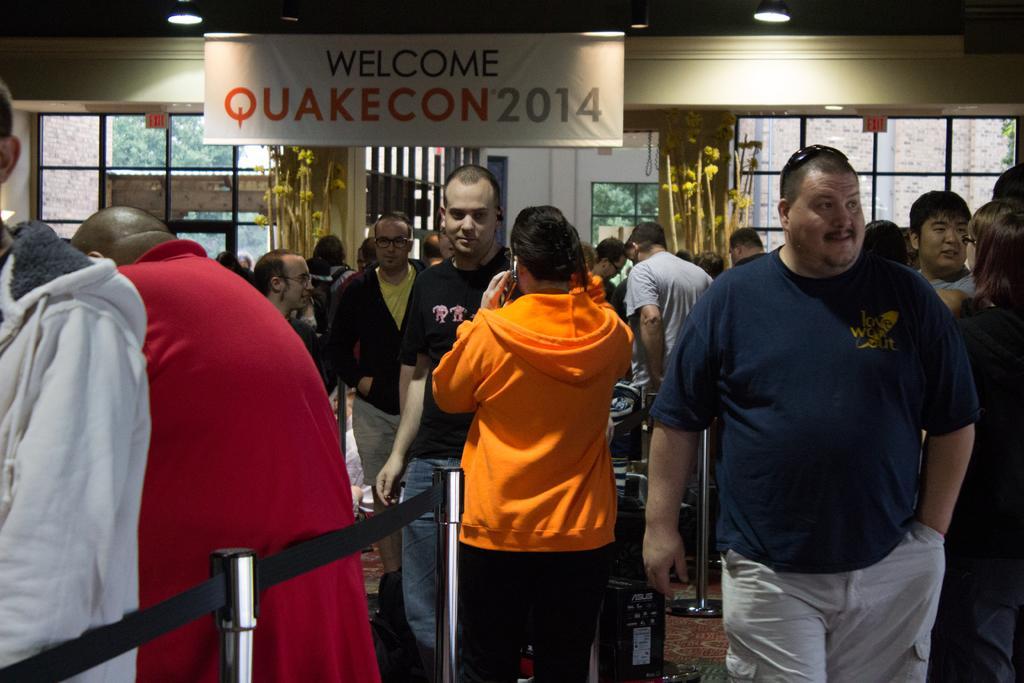How would you summarize this image in a sentence or two? In this image, in the middle there is a woman, she wears a jacket, trouser, in front of her there is a man. In the background there are people, banner, text, plants, windows, glasses, doors, lights, trees, wall, roof. On the right there are two people. On the left there is a man, he is walking. 